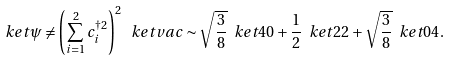<formula> <loc_0><loc_0><loc_500><loc_500>\ k e t { \psi } \neq \left ( \sum _ { i = 1 } ^ { 2 } c _ { i } ^ { \dagger 2 } \right ) ^ { 2 } \ k e t { v a c } \sim \sqrt { \frac { 3 } { 8 } } \ k e t { 4 0 } + \frac { 1 } { 2 } \ k e t { 2 2 } + \sqrt { \frac { 3 } { 8 } } \ k e t { 0 4 } .</formula> 